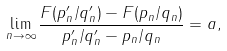Convert formula to latex. <formula><loc_0><loc_0><loc_500><loc_500>\lim _ { n \to \infty } \frac { F ( p ^ { \prime } _ { n } / q ^ { \prime } _ { n } ) - F ( p _ { n } / q _ { n } ) } { p ^ { \prime } _ { n } / q ^ { \prime } _ { n } - p _ { n } / q _ { n } } = a ,</formula> 